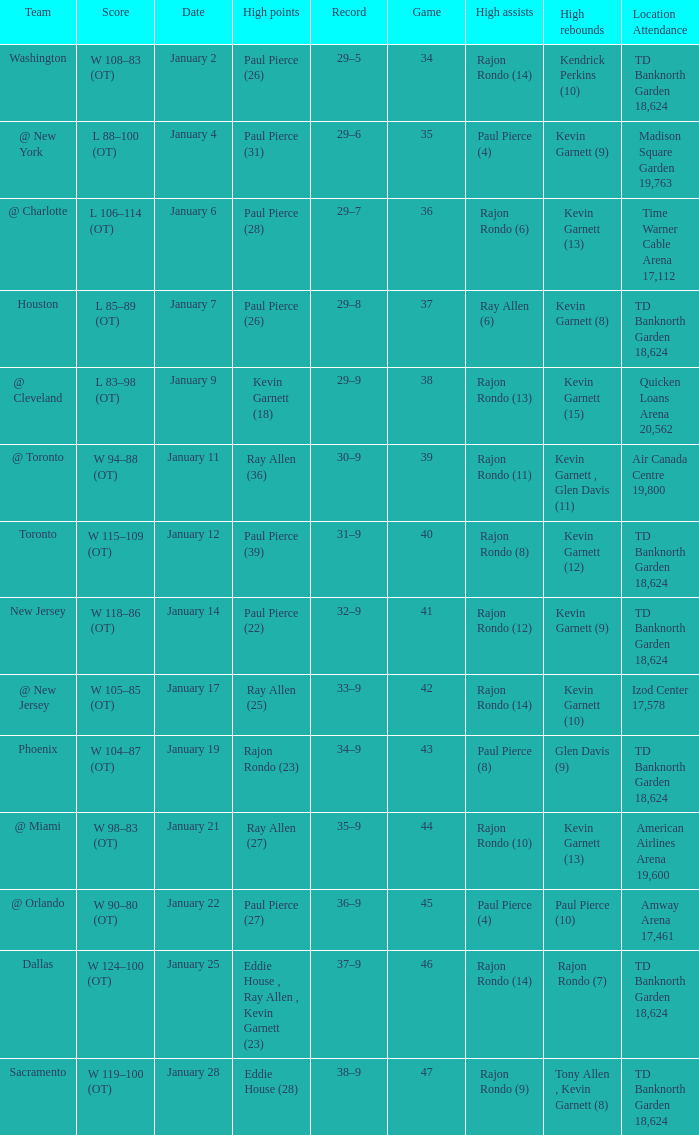Parse the full table. {'header': ['Team', 'Score', 'Date', 'High points', 'Record', 'Game', 'High assists', 'High rebounds', 'Location Attendance'], 'rows': [['Washington', 'W 108–83 (OT)', 'January 2', 'Paul Pierce (26)', '29–5', '34', 'Rajon Rondo (14)', 'Kendrick Perkins (10)', 'TD Banknorth Garden 18,624'], ['@ New York', 'L 88–100 (OT)', 'January 4', 'Paul Pierce (31)', '29–6', '35', 'Paul Pierce (4)', 'Kevin Garnett (9)', 'Madison Square Garden 19,763'], ['@ Charlotte', 'L 106–114 (OT)', 'January 6', 'Paul Pierce (28)', '29–7', '36', 'Rajon Rondo (6)', 'Kevin Garnett (13)', 'Time Warner Cable Arena 17,112'], ['Houston', 'L 85–89 (OT)', 'January 7', 'Paul Pierce (26)', '29–8', '37', 'Ray Allen (6)', 'Kevin Garnett (8)', 'TD Banknorth Garden 18,624'], ['@ Cleveland', 'L 83–98 (OT)', 'January 9', 'Kevin Garnett (18)', '29–9', '38', 'Rajon Rondo (13)', 'Kevin Garnett (15)', 'Quicken Loans Arena 20,562'], ['@ Toronto', 'W 94–88 (OT)', 'January 11', 'Ray Allen (36)', '30–9', '39', 'Rajon Rondo (11)', 'Kevin Garnett , Glen Davis (11)', 'Air Canada Centre 19,800'], ['Toronto', 'W 115–109 (OT)', 'January 12', 'Paul Pierce (39)', '31–9', '40', 'Rajon Rondo (8)', 'Kevin Garnett (12)', 'TD Banknorth Garden 18,624'], ['New Jersey', 'W 118–86 (OT)', 'January 14', 'Paul Pierce (22)', '32–9', '41', 'Rajon Rondo (12)', 'Kevin Garnett (9)', 'TD Banknorth Garden 18,624'], ['@ New Jersey', 'W 105–85 (OT)', 'January 17', 'Ray Allen (25)', '33–9', '42', 'Rajon Rondo (14)', 'Kevin Garnett (10)', 'Izod Center 17,578'], ['Phoenix', 'W 104–87 (OT)', 'January 19', 'Rajon Rondo (23)', '34–9', '43', 'Paul Pierce (8)', 'Glen Davis (9)', 'TD Banknorth Garden 18,624'], ['@ Miami', 'W 98–83 (OT)', 'January 21', 'Ray Allen (27)', '35–9', '44', 'Rajon Rondo (10)', 'Kevin Garnett (13)', 'American Airlines Arena 19,600'], ['@ Orlando', 'W 90–80 (OT)', 'January 22', 'Paul Pierce (27)', '36–9', '45', 'Paul Pierce (4)', 'Paul Pierce (10)', 'Amway Arena 17,461'], ['Dallas', 'W 124–100 (OT)', 'January 25', 'Eddie House , Ray Allen , Kevin Garnett (23)', '37–9', '46', 'Rajon Rondo (14)', 'Rajon Rondo (7)', 'TD Banknorth Garden 18,624'], ['Sacramento', 'W 119–100 (OT)', 'January 28', 'Eddie House (28)', '38–9', '47', 'Rajon Rondo (9)', 'Tony Allen , Kevin Garnett (8)', 'TD Banknorth Garden 18,624']]} Who had the high rebound total on january 6? Kevin Garnett (13). 